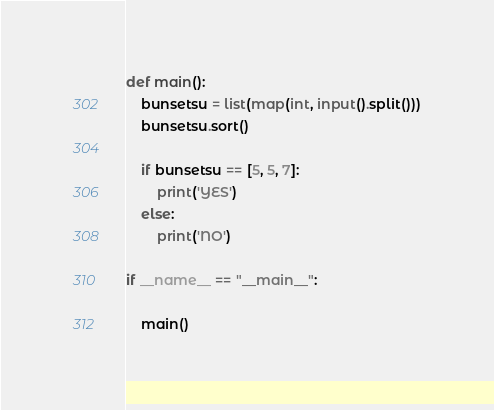Convert code to text. <code><loc_0><loc_0><loc_500><loc_500><_Python_>def main():
    bunsetsu = list(map(int, input().split()))
    bunsetsu.sort()

    if bunsetsu == [5, 5, 7]:
        print('YES')
    else:
        print('NO')

if __name__ == "__main__":

    main()
</code> 